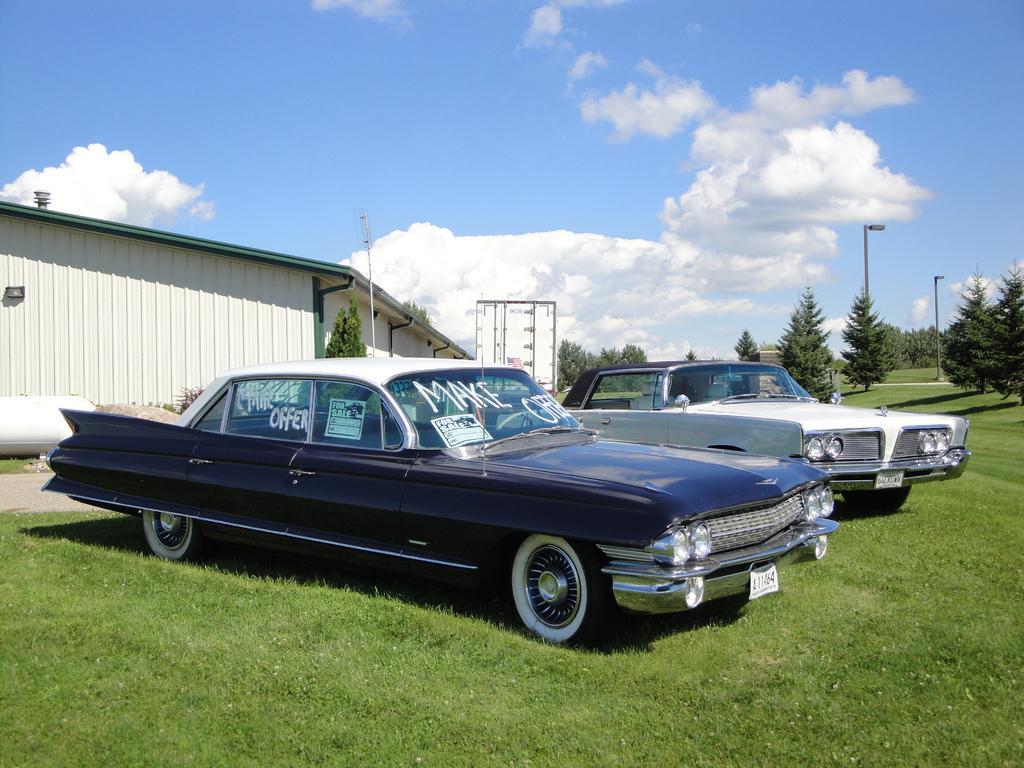Describe this image in one or two sentences. In this image we can see vehicles on the grass on the ground. In the background there are trees, light poles, house and clouds in the sky. 